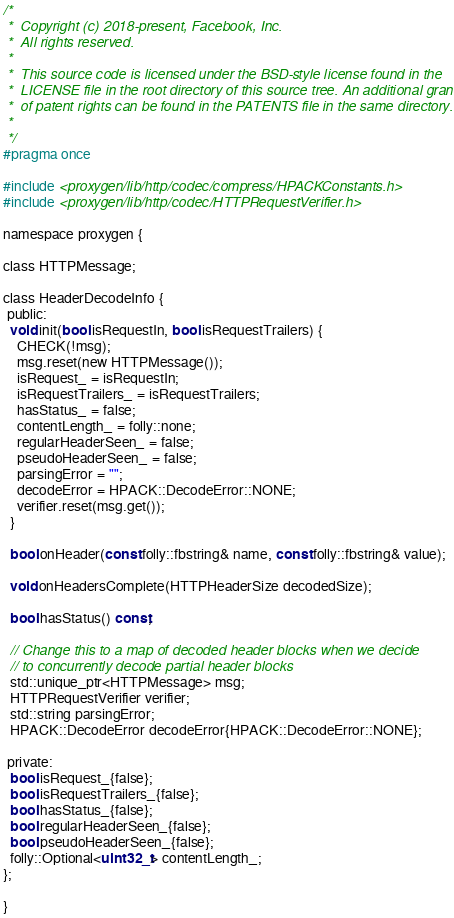Convert code to text. <code><loc_0><loc_0><loc_500><loc_500><_C_>/*
 *  Copyright (c) 2018-present, Facebook, Inc.
 *  All rights reserved.
 *
 *  This source code is licensed under the BSD-style license found in the
 *  LICENSE file in the root directory of this source tree. An additional grant
 *  of patent rights can be found in the PATENTS file in the same directory.
 *
 */
#pragma once

#include <proxygen/lib/http/codec/compress/HPACKConstants.h>
#include <proxygen/lib/http/codec/HTTPRequestVerifier.h>

namespace proxygen {

class HTTPMessage;

class HeaderDecodeInfo {
 public:
  void init(bool isRequestIn, bool isRequestTrailers) {
    CHECK(!msg);
    msg.reset(new HTTPMessage());
    isRequest_ = isRequestIn;
    isRequestTrailers_ = isRequestTrailers;
    hasStatus_ = false;
    contentLength_ = folly::none;
    regularHeaderSeen_ = false;
    pseudoHeaderSeen_ = false;
    parsingError = "";
    decodeError = HPACK::DecodeError::NONE;
    verifier.reset(msg.get());
  }

  bool onHeader(const folly::fbstring& name, const folly::fbstring& value);

  void onHeadersComplete(HTTPHeaderSize decodedSize);

  bool hasStatus() const;

  // Change this to a map of decoded header blocks when we decide
  // to concurrently decode partial header blocks
  std::unique_ptr<HTTPMessage> msg;
  HTTPRequestVerifier verifier;
  std::string parsingError;
  HPACK::DecodeError decodeError{HPACK::DecodeError::NONE};

 private:
  bool isRequest_{false};
  bool isRequestTrailers_{false};
  bool hasStatus_{false};
  bool regularHeaderSeen_{false};
  bool pseudoHeaderSeen_{false};
  folly::Optional<uint32_t> contentLength_;
};

}
</code> 